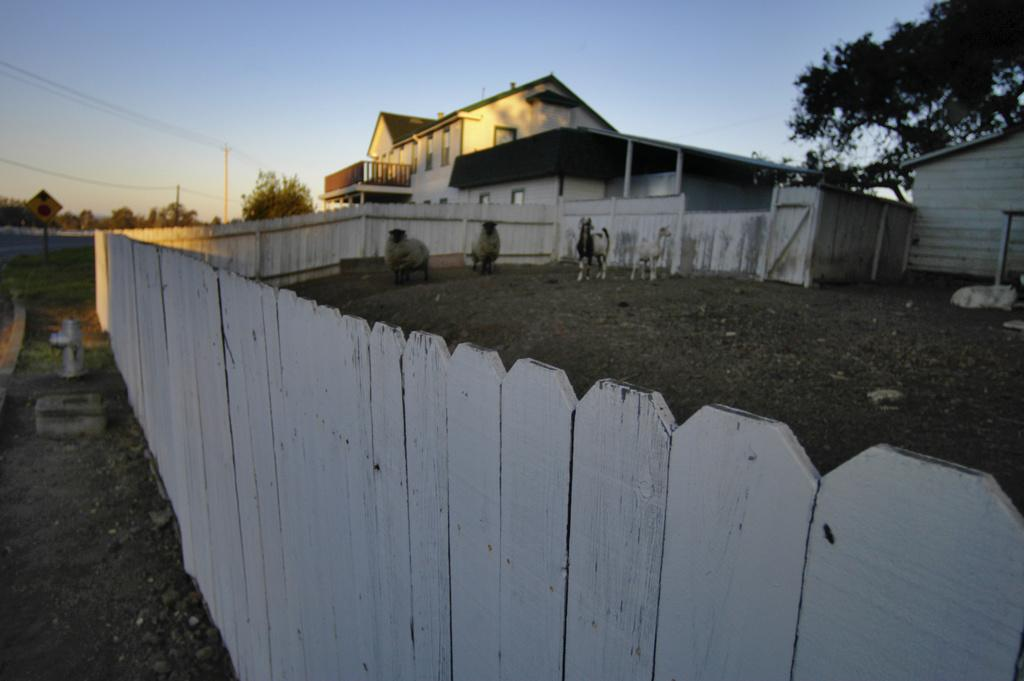What types of living organisms can be seen in the image? There are animals in the image. What is the barrier that separates the animals from the background? There is a fence in the image. What can be seen in the distance behind the fence? There are buildings, trees, poles, wires, and the sky visible in the background of the image. What type of quince is being used to decorate the coat in the image? There is no quince or coat present in the image. 